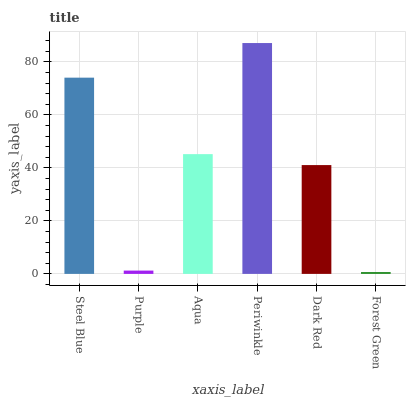Is Forest Green the minimum?
Answer yes or no. Yes. Is Periwinkle the maximum?
Answer yes or no. Yes. Is Purple the minimum?
Answer yes or no. No. Is Purple the maximum?
Answer yes or no. No. Is Steel Blue greater than Purple?
Answer yes or no. Yes. Is Purple less than Steel Blue?
Answer yes or no. Yes. Is Purple greater than Steel Blue?
Answer yes or no. No. Is Steel Blue less than Purple?
Answer yes or no. No. Is Aqua the high median?
Answer yes or no. Yes. Is Dark Red the low median?
Answer yes or no. Yes. Is Purple the high median?
Answer yes or no. No. Is Steel Blue the low median?
Answer yes or no. No. 